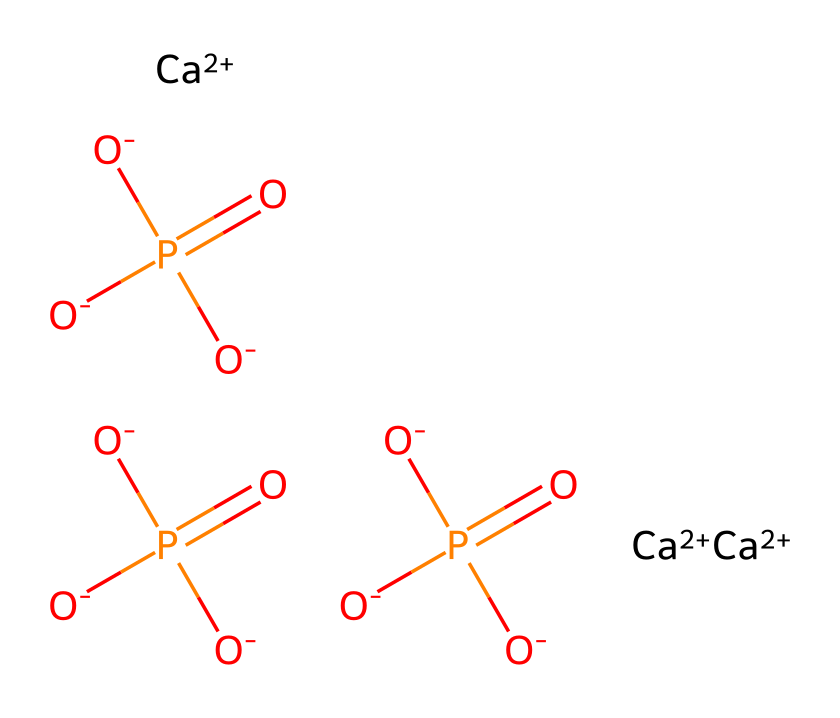What is the primary calcium ion in this compound? The structure shows multiple instances of calcium ions, denoted by [Ca+2]. This indicates that calcium is present in a +2 oxidation state, as is typical in calcium phosphate compounds.
Answer: calcium How many phosphate groups are present in the molecule? The structure contains three instances of the phosphate groups, represented by [O-]P([O-])([O-])=O. This indicates there are three phosphorous atoms, each with the phosphate structure.
Answer: three What type of bonds are indicated by the phosphorus atoms in the molecule? Phosphorus atoms in phosphate groups show multiple P=O double bonds and P-O single bonds, as noted in the structure. This reveals the types of bonds that characterize the phosphate functional groups.
Answer: double and single bonds What is the overall charge of the compound based on the provided ions? In the structure, there are three calcium ions, each with a +2 charge, contributing a total of +6 charge, while the three phosphate groups, each having a -2 charge, give a total of -6 charge. The charges balance to neutral overall.
Answer: neutral How does the arrangement of calcium and phosphate affect the stability of the compound? The structural arrangement shows calcium ions surrounded by phosphate groups, creating a rigid lattice structure that stabilizes the compound. This arrangement enhances stability due to ionic bonding between the positive calcium ions and negatively charged phosphate groups.
Answer: stable 